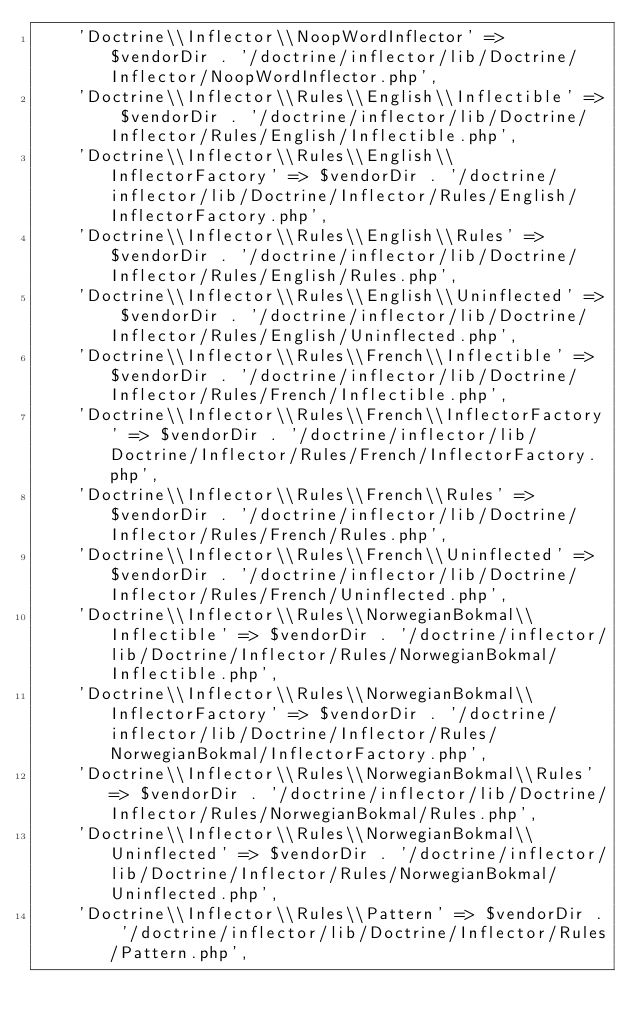<code> <loc_0><loc_0><loc_500><loc_500><_PHP_>    'Doctrine\\Inflector\\NoopWordInflector' => $vendorDir . '/doctrine/inflector/lib/Doctrine/Inflector/NoopWordInflector.php',
    'Doctrine\\Inflector\\Rules\\English\\Inflectible' => $vendorDir . '/doctrine/inflector/lib/Doctrine/Inflector/Rules/English/Inflectible.php',
    'Doctrine\\Inflector\\Rules\\English\\InflectorFactory' => $vendorDir . '/doctrine/inflector/lib/Doctrine/Inflector/Rules/English/InflectorFactory.php',
    'Doctrine\\Inflector\\Rules\\English\\Rules' => $vendorDir . '/doctrine/inflector/lib/Doctrine/Inflector/Rules/English/Rules.php',
    'Doctrine\\Inflector\\Rules\\English\\Uninflected' => $vendorDir . '/doctrine/inflector/lib/Doctrine/Inflector/Rules/English/Uninflected.php',
    'Doctrine\\Inflector\\Rules\\French\\Inflectible' => $vendorDir . '/doctrine/inflector/lib/Doctrine/Inflector/Rules/French/Inflectible.php',
    'Doctrine\\Inflector\\Rules\\French\\InflectorFactory' => $vendorDir . '/doctrine/inflector/lib/Doctrine/Inflector/Rules/French/InflectorFactory.php',
    'Doctrine\\Inflector\\Rules\\French\\Rules' => $vendorDir . '/doctrine/inflector/lib/Doctrine/Inflector/Rules/French/Rules.php',
    'Doctrine\\Inflector\\Rules\\French\\Uninflected' => $vendorDir . '/doctrine/inflector/lib/Doctrine/Inflector/Rules/French/Uninflected.php',
    'Doctrine\\Inflector\\Rules\\NorwegianBokmal\\Inflectible' => $vendorDir . '/doctrine/inflector/lib/Doctrine/Inflector/Rules/NorwegianBokmal/Inflectible.php',
    'Doctrine\\Inflector\\Rules\\NorwegianBokmal\\InflectorFactory' => $vendorDir . '/doctrine/inflector/lib/Doctrine/Inflector/Rules/NorwegianBokmal/InflectorFactory.php',
    'Doctrine\\Inflector\\Rules\\NorwegianBokmal\\Rules' => $vendorDir . '/doctrine/inflector/lib/Doctrine/Inflector/Rules/NorwegianBokmal/Rules.php',
    'Doctrine\\Inflector\\Rules\\NorwegianBokmal\\Uninflected' => $vendorDir . '/doctrine/inflector/lib/Doctrine/Inflector/Rules/NorwegianBokmal/Uninflected.php',
    'Doctrine\\Inflector\\Rules\\Pattern' => $vendorDir . '/doctrine/inflector/lib/Doctrine/Inflector/Rules/Pattern.php',</code> 